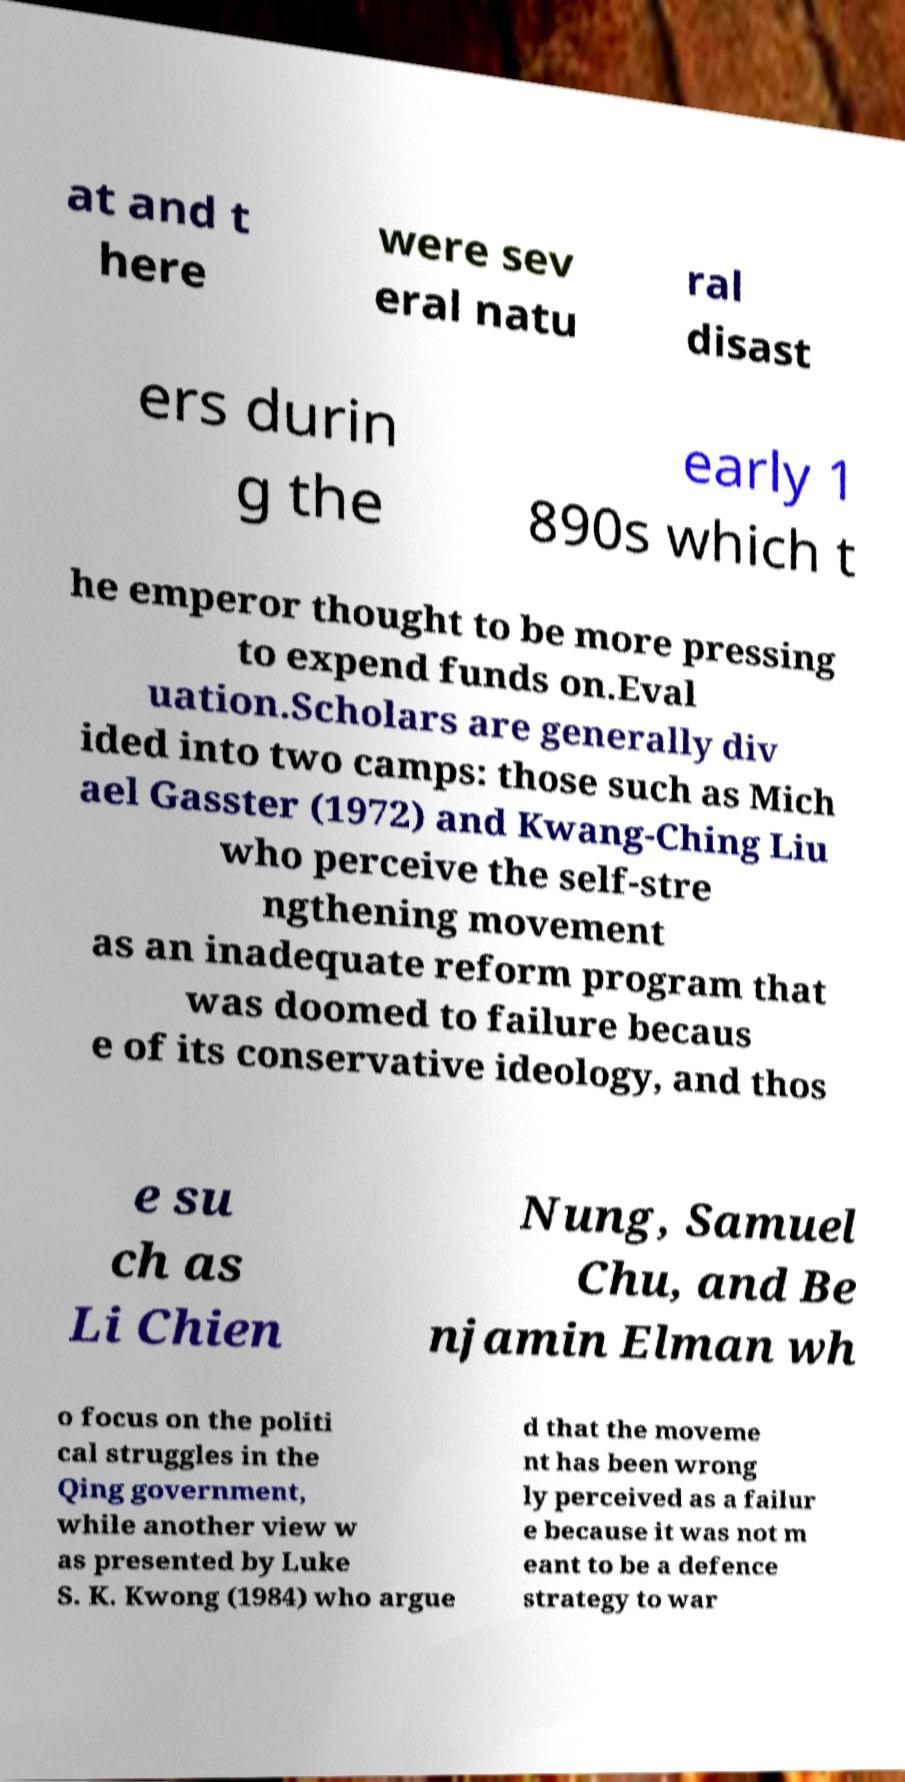Can you accurately transcribe the text from the provided image for me? at and t here were sev eral natu ral disast ers durin g the early 1 890s which t he emperor thought to be more pressing to expend funds on.Eval uation.Scholars are generally div ided into two camps: those such as Mich ael Gasster (1972) and Kwang-Ching Liu who perceive the self-stre ngthening movement as an inadequate reform program that was doomed to failure becaus e of its conservative ideology, and thos e su ch as Li Chien Nung, Samuel Chu, and Be njamin Elman wh o focus on the politi cal struggles in the Qing government, while another view w as presented by Luke S. K. Kwong (1984) who argue d that the moveme nt has been wrong ly perceived as a failur e because it was not m eant to be a defence strategy to war 